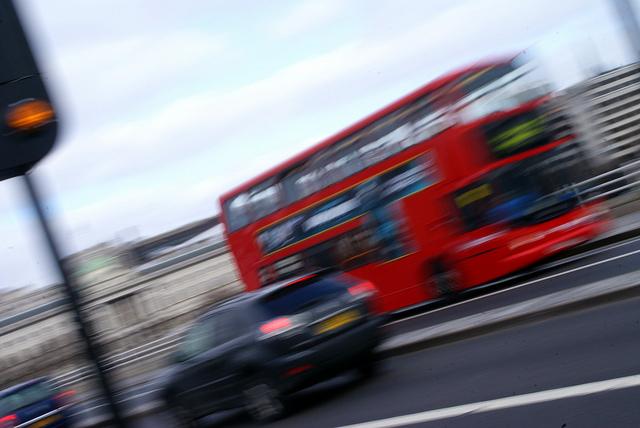What color is the truck next to the bus?
Write a very short answer. Black. What color is the bus?
Give a very brief answer. Red. Is this a tourist bus?
Write a very short answer. Yes. 